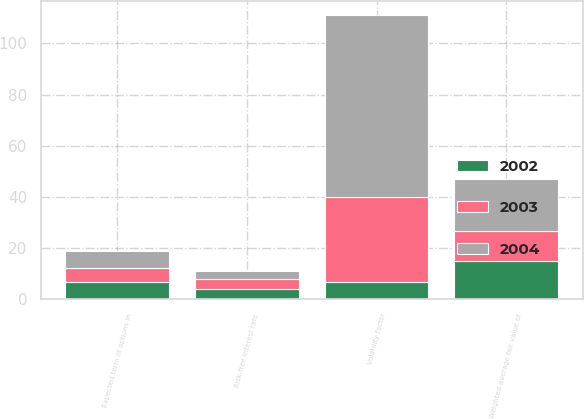<chart> <loc_0><loc_0><loc_500><loc_500><stacked_bar_chart><ecel><fcel>Risk-free interest rate<fcel>Volatility factor<fcel>Expected term of options in<fcel>Weighted-average fair value of<nl><fcel>2003<fcel>3.69<fcel>33.26<fcel>5.4<fcel>11.66<nl><fcel>2004<fcel>3.32<fcel>71.08<fcel>6.7<fcel>20.38<nl><fcel>2002<fcel>4.14<fcel>6.7<fcel>6.7<fcel>15.08<nl></chart> 